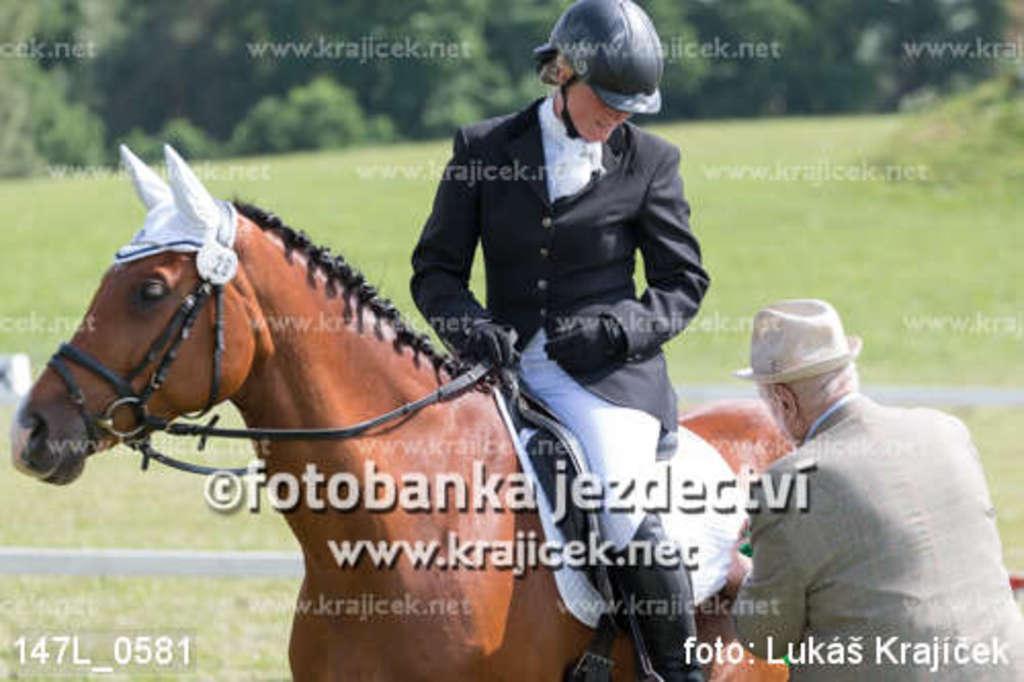Can you describe this image briefly? In this picture we can see some text, two people and a man wore a helmet, gloves and sitting on a horse and in the background we can see the grass, trees. 